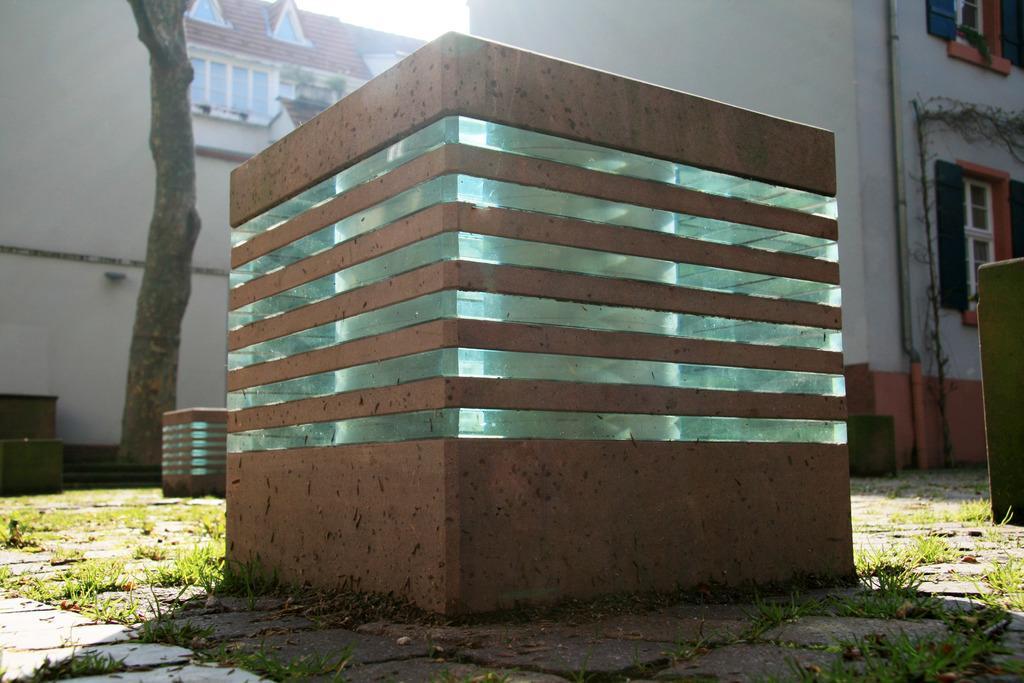Could you give a brief overview of what you see in this image? In this picture there is a garden fixture lights placed on the ground. Behind there is a building and windows and a tree trunk. 